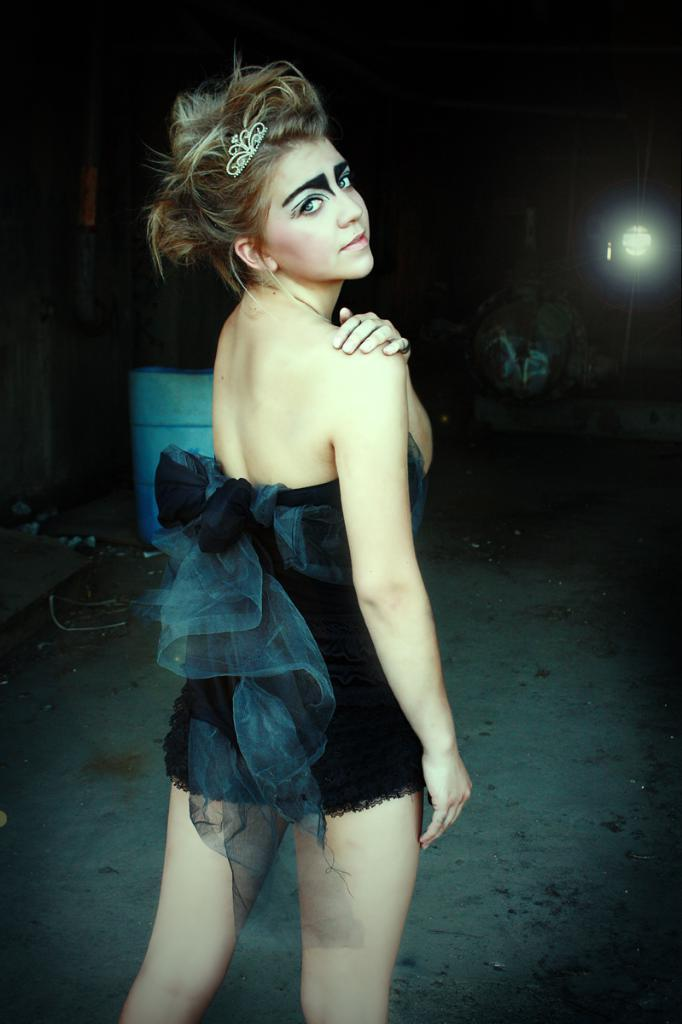Who is the main subject in the image? There is a lady in the image. What is the lady wearing? The lady is wearing a black dress and a crown. What can be observed about the background of the image? The background of the image is dark. Can you describe any light source in the image? Yes, there is a light in the image. How many hills can be seen in the image? There are no hills visible in the image. 